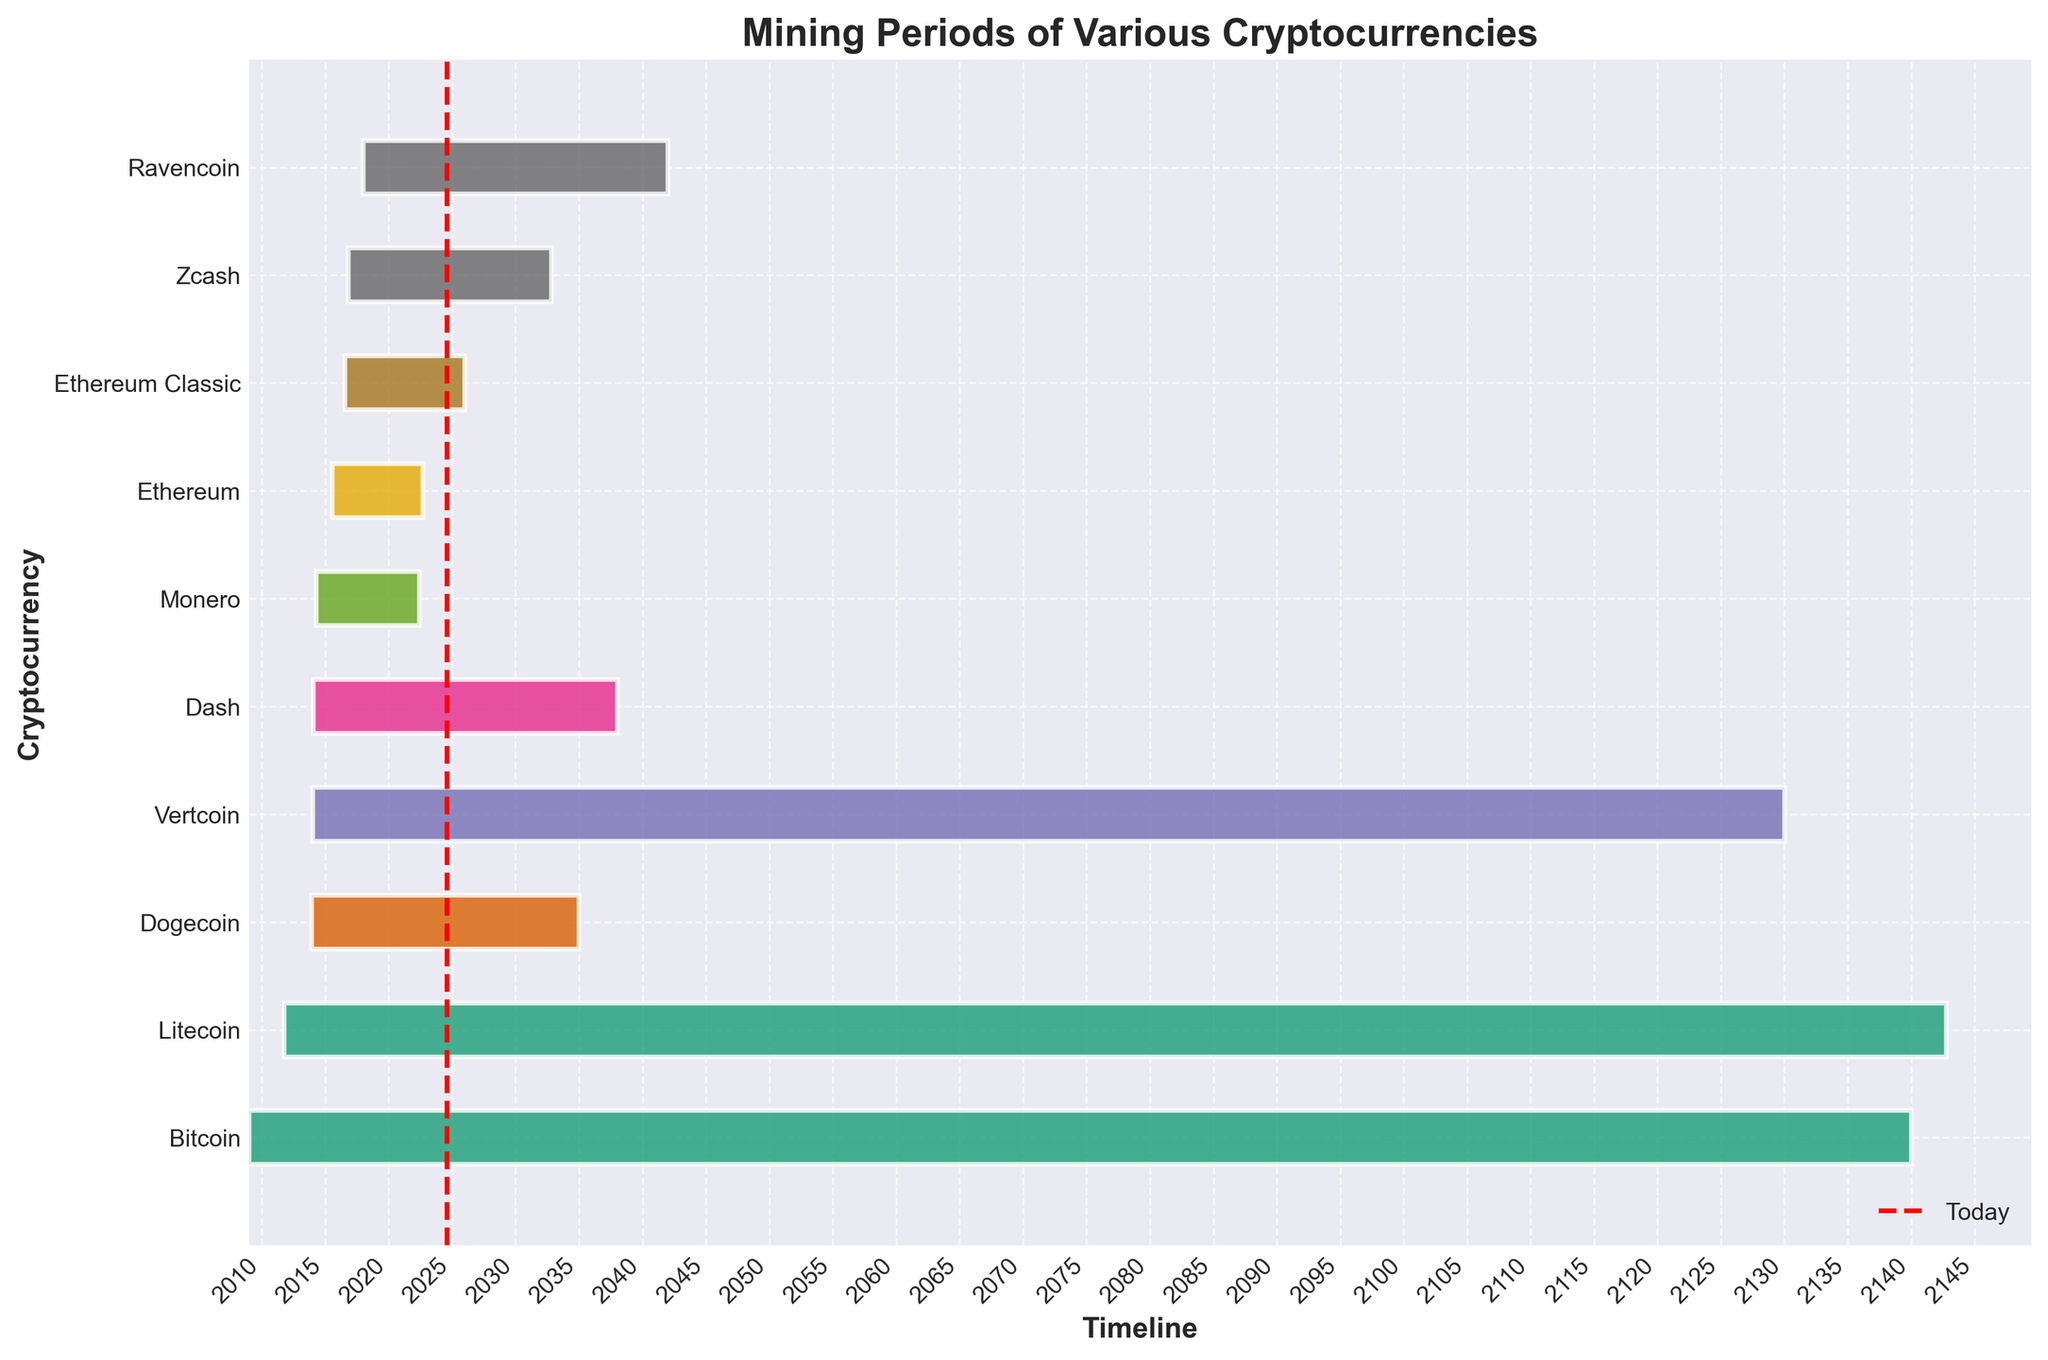What is the title of the figure? The title is often located at the top of the figure and provides a summary of what the visualization is about. In this case, it directly tells us the content.
Answer: Mining Periods of Various Cryptocurrencies Which cryptocurrency has the longest mining period? By observing the horizontal bars, the length from the start to the end date indicates the duration of mining. The longest bar indicates the longest mining period.
Answer: Litecoin What cryptocurrency's mining period is expected to end first? The end date on the right side of the bars shows when the mining period ends. The bar that ends first (leftmost end date) indicates the first to end.
Answer: Ethereum Classic How many cryptocurrencies have their mining period ending in the 21st century? We count the bars that end before the year 2100 on the timeline.
Answer: 5 Which two cryptocurrencies started their mining period closest to each other? By observing the start dates (left edge of the bars), the two bars that begin next to each other on the timeline are the closest.
Answer: Dash and Vertcoin How does the mining period of Monero compare to that of Bitcoin? Look at the length of the horizontal bars for Monero and Bitcoin. Comparing their start and end dates will illustrate the difference in mining periods.
Answer: Bitcoin has a much longer mining period than Monero Among Ravencoin, Vertcoin, and Dogecoin, which has the shortest expected mining period? By observing and measuring the length of the horizontal bars for Ravencoin, Vertcoin, and Dogecoin, the shortest bar indicates the shortest mining period.
Answer: Dogecoin Which cryptocurrency started mining operations most recently? The most recent start date will be the last bar to start from the left side.
Answer: Ravencoin How many cryptocurrencies have been mining since before 2015? We count the number of bars with a start date before 2015.
Answer: 6 What is the color used for Bitcoin's mining period bar? This requires visually identifying the color associated with the Bitcoin bar on the chart, which is uniquely identified.
Answer: Color from the color map used in the chart (subject to the actual color displayed) 